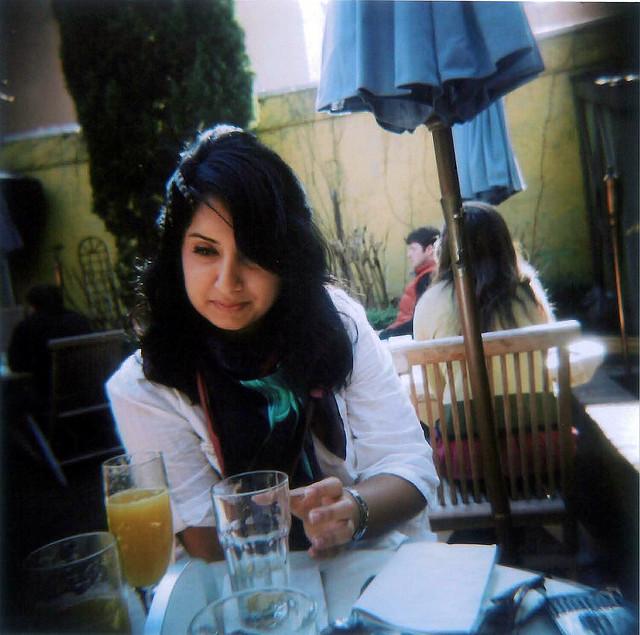Are the umbrellas open?
Short answer required. No. Is she reaching?
Quick response, please. Yes. Is this girl drinking orange juice?
Write a very short answer. Yes. 